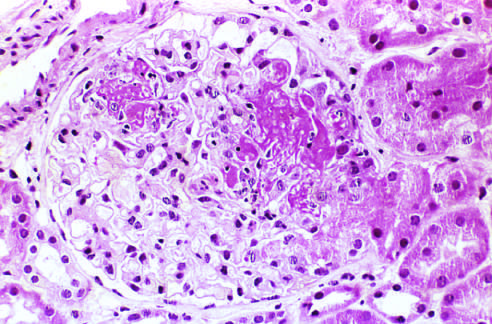s extracapillary proliferation not prominent in this case?
Answer the question using a single word or phrase. Yes 